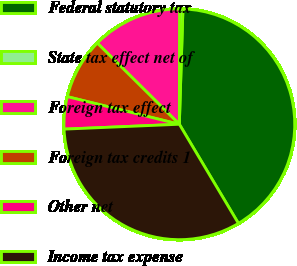Convert chart. <chart><loc_0><loc_0><loc_500><loc_500><pie_chart><fcel>Federal statutory tax<fcel>State tax effect net of<fcel>Foreign tax effect<fcel>Foreign tax credits 1<fcel>Other net<fcel>Income tax expense<nl><fcel>40.95%<fcel>0.47%<fcel>12.61%<fcel>8.57%<fcel>4.52%<fcel>32.88%<nl></chart> 